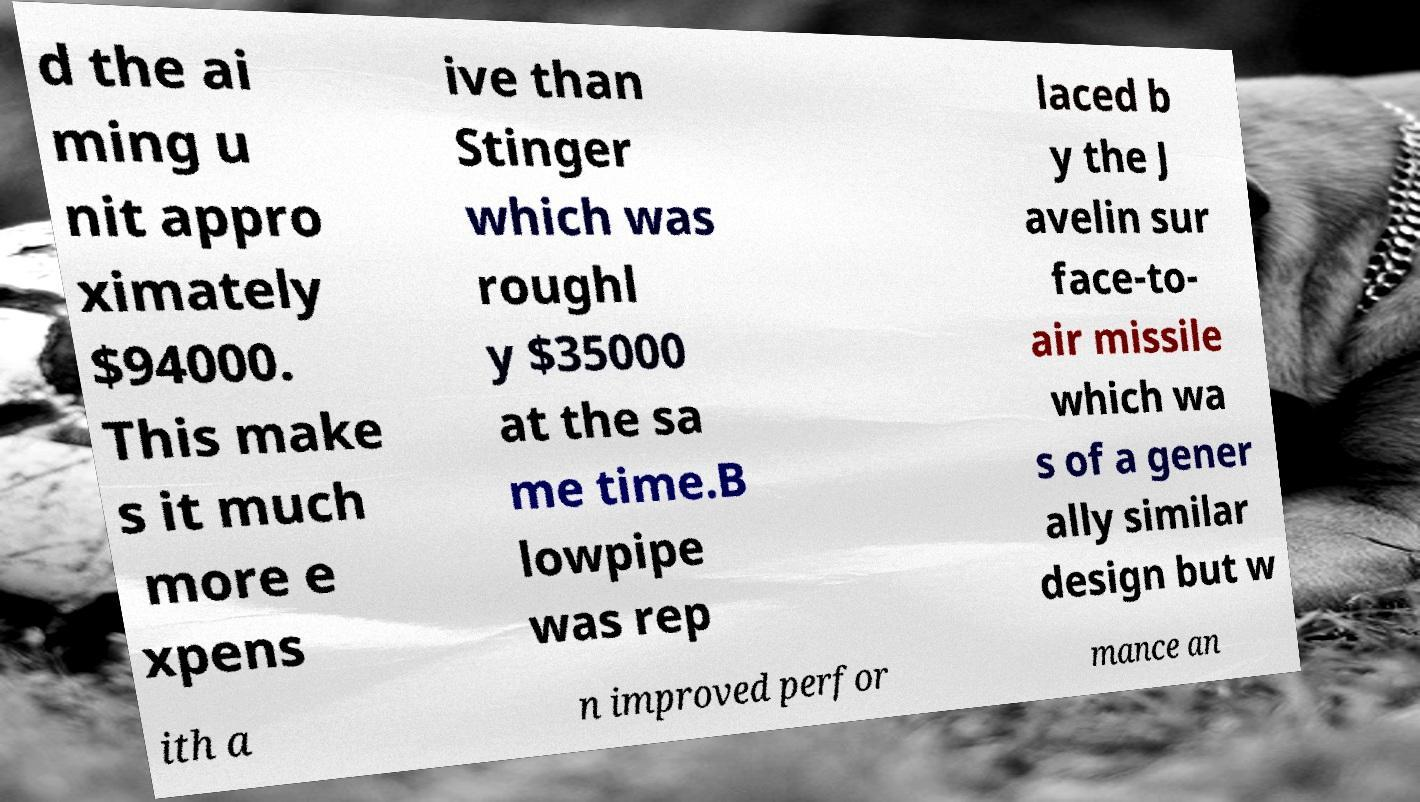I need the written content from this picture converted into text. Can you do that? d the ai ming u nit appro ximately $94000. This make s it much more e xpens ive than Stinger which was roughl y $35000 at the sa me time.B lowpipe was rep laced b y the J avelin sur face-to- air missile which wa s of a gener ally similar design but w ith a n improved perfor mance an 